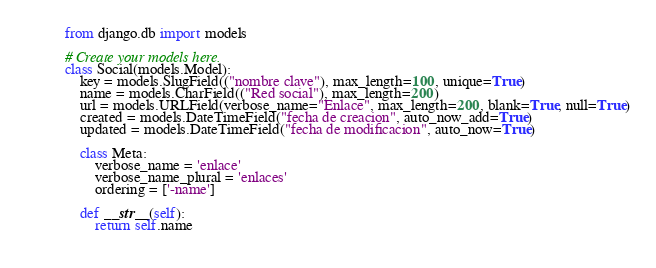<code> <loc_0><loc_0><loc_500><loc_500><_Python_>from django.db import models

# Create your models here.
class Social(models.Model):
    key = models.SlugField(("nombre clave"), max_length=100, unique=True)
    name = models.CharField(("Red social"), max_length=200)
    url = models.URLField(verbose_name="Enlace", max_length=200, blank=True, null=True)
    created = models.DateTimeField("fecha de creacion", auto_now_add=True)
    updated = models.DateTimeField("fecha de modificacion", auto_now=True)

    class Meta:
        verbose_name = 'enlace'
        verbose_name_plural = 'enlaces'
        ordering = ['-name']

    def __str__(self):
        return self.name
    </code> 